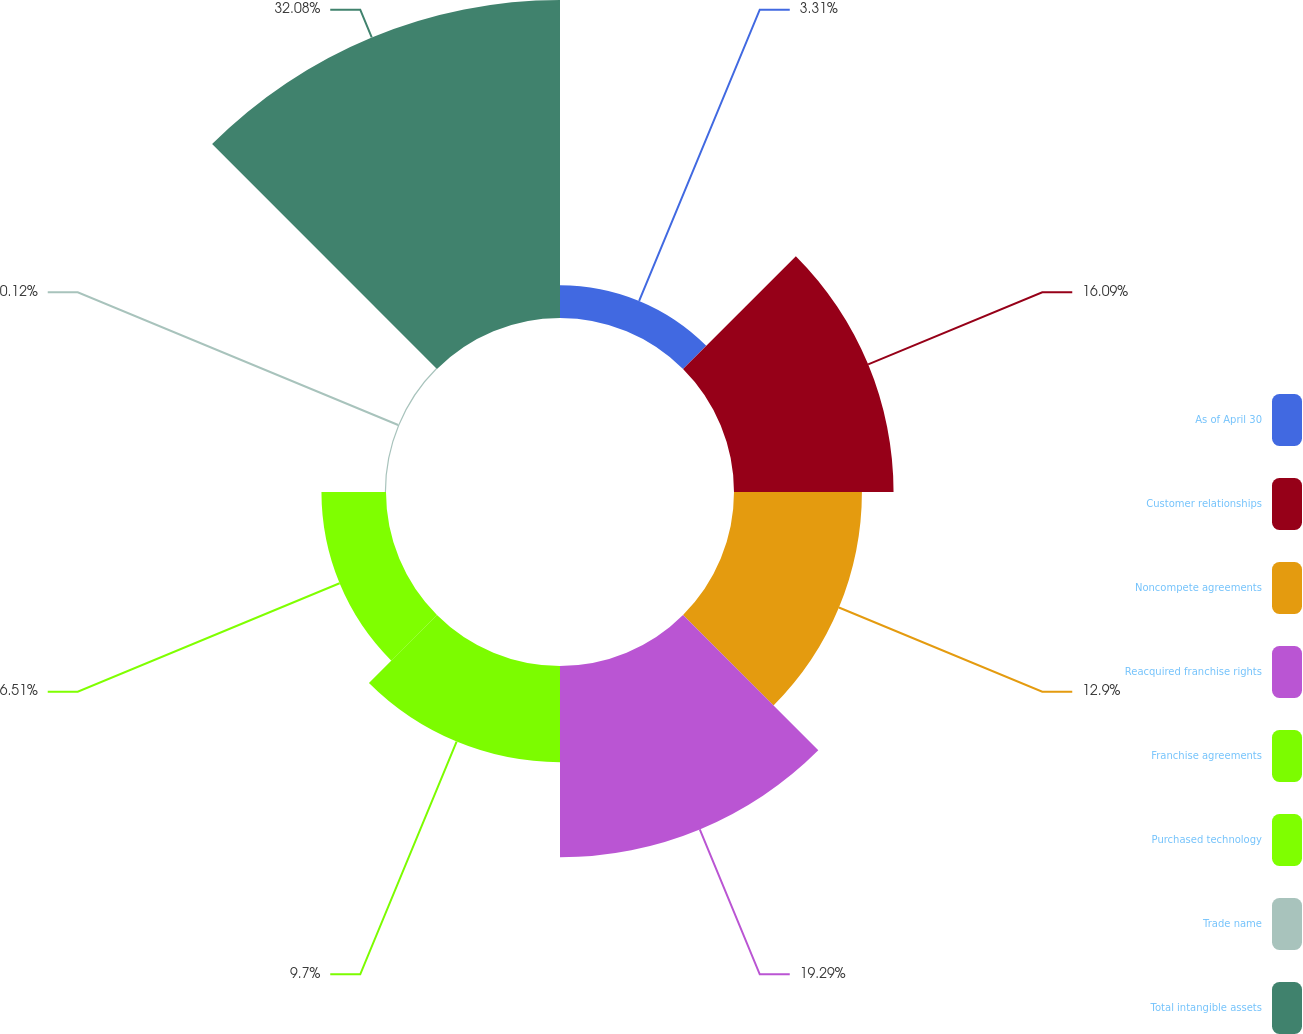Convert chart. <chart><loc_0><loc_0><loc_500><loc_500><pie_chart><fcel>As of April 30<fcel>Customer relationships<fcel>Noncompete agreements<fcel>Reacquired franchise rights<fcel>Franchise agreements<fcel>Purchased technology<fcel>Trade name<fcel>Total intangible assets<nl><fcel>3.31%<fcel>16.09%<fcel>12.9%<fcel>19.29%<fcel>9.7%<fcel>6.51%<fcel>0.12%<fcel>32.07%<nl></chart> 